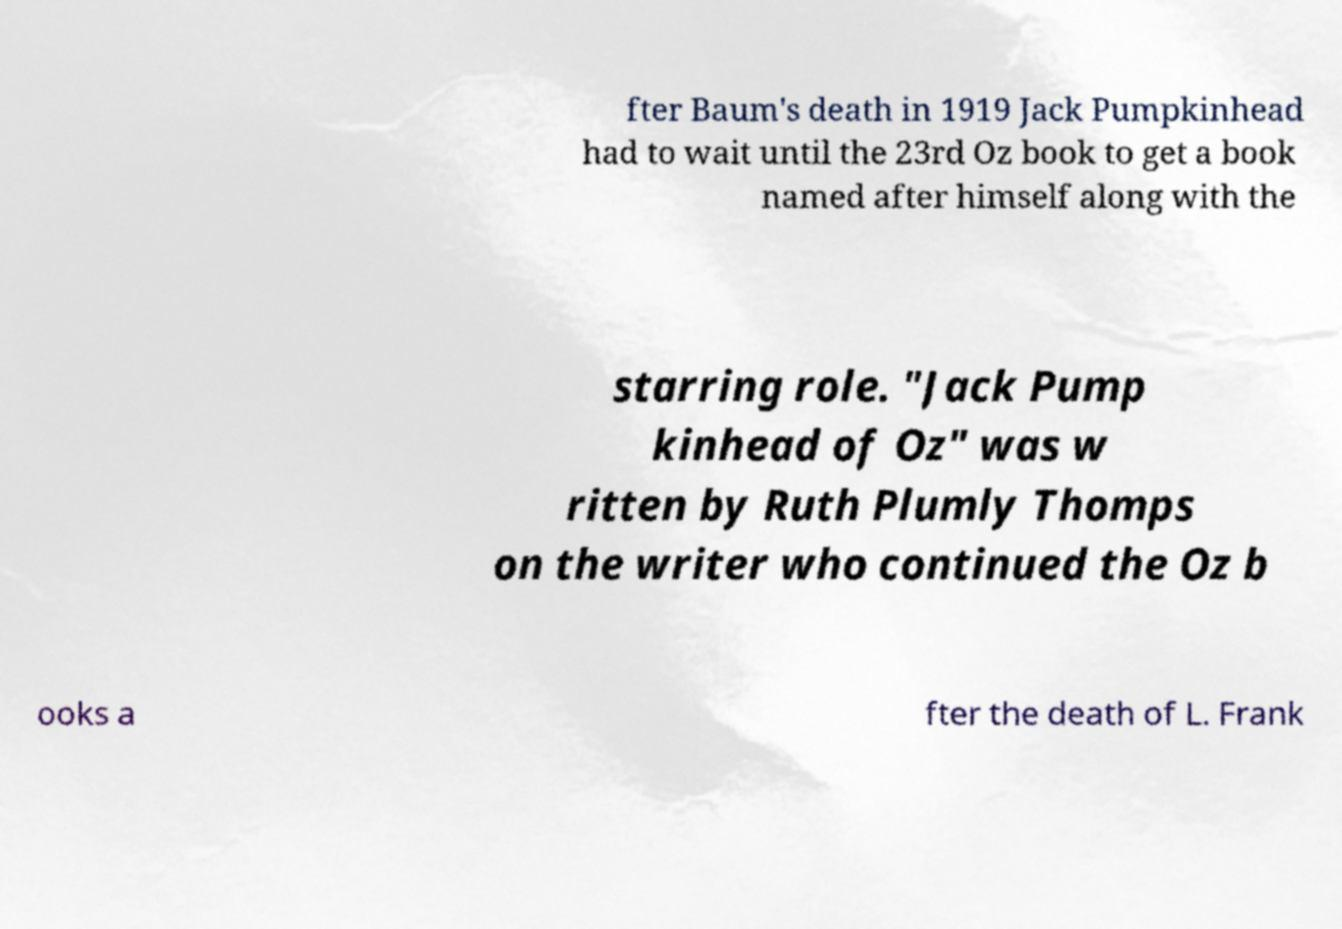Please read and relay the text visible in this image. What does it say? fter Baum's death in 1919 Jack Pumpkinhead had to wait until the 23rd Oz book to get a book named after himself along with the starring role. "Jack Pump kinhead of Oz" was w ritten by Ruth Plumly Thomps on the writer who continued the Oz b ooks a fter the death of L. Frank 